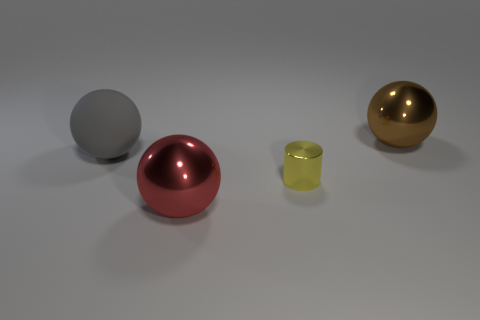Are there any other things that are the same shape as the yellow object?
Keep it short and to the point. No. Is there a yellow thing that has the same material as the large red thing?
Provide a succinct answer. Yes. What is the material of the brown thing that is the same size as the gray rubber sphere?
Make the answer very short. Metal. There is a object that is to the left of the tiny yellow object and in front of the large gray rubber ball; what is its size?
Your answer should be very brief. Large. There is a thing that is both on the left side of the cylinder and in front of the gray rubber object; what color is it?
Offer a very short reply. Red. Is the number of large gray rubber objects that are on the right side of the brown shiny object less than the number of tiny yellow cylinders that are behind the gray object?
Ensure brevity in your answer.  No. How many other red objects have the same shape as the big red object?
Give a very brief answer. 0. The red sphere that is made of the same material as the big brown thing is what size?
Provide a short and direct response. Large. There is a large metal ball that is on the right side of the large sphere that is in front of the big gray object; what is its color?
Ensure brevity in your answer.  Brown. There is a large gray thing; is it the same shape as the big thing in front of the yellow metal thing?
Provide a short and direct response. Yes. 